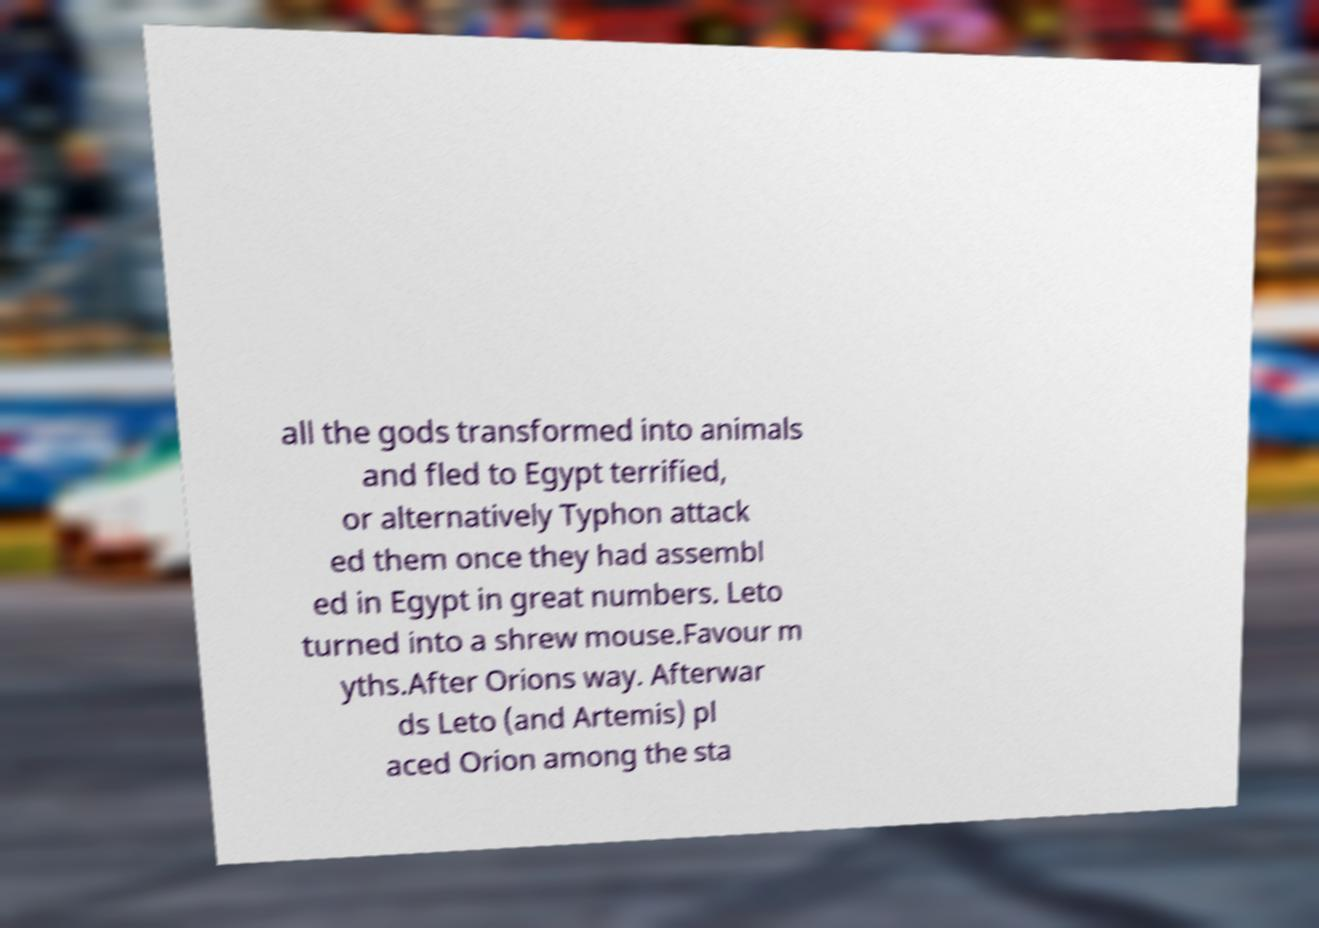Could you assist in decoding the text presented in this image and type it out clearly? all the gods transformed into animals and fled to Egypt terrified, or alternatively Typhon attack ed them once they had assembl ed in Egypt in great numbers. Leto turned into a shrew mouse.Favour m yths.After Orions way. Afterwar ds Leto (and Artemis) pl aced Orion among the sta 